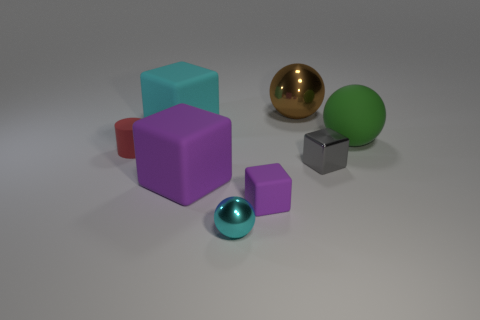There is a block behind the small thing that is to the left of the shiny ball that is in front of the red cylinder; what size is it?
Give a very brief answer. Large. What number of small cyan things are behind the brown metallic sphere?
Keep it short and to the point. 0. Is the number of gray metallic objects greater than the number of small red shiny cubes?
Your answer should be compact. Yes. What is the size of the object that is the same color as the tiny shiny sphere?
Offer a very short reply. Large. How big is the metallic thing that is in front of the large brown sphere and on the right side of the small cyan metal thing?
Keep it short and to the point. Small. What material is the big cube that is in front of the large matte sphere that is to the right of the large rubber thing that is in front of the tiny gray cube?
Make the answer very short. Rubber. There is a metal sphere that is on the left side of the brown thing; is it the same color as the cube that is behind the tiny cylinder?
Your answer should be compact. Yes. What is the shape of the big matte thing to the right of the shiny sphere behind the small metallic ball that is left of the large green thing?
Provide a succinct answer. Sphere. There is a big object that is left of the tiny cyan metallic object and right of the big cyan matte object; what is its shape?
Give a very brief answer. Cube. There is a tiny block that is on the left side of the metal ball that is behind the tiny red matte thing; what number of big spheres are on the left side of it?
Your response must be concise. 0. 